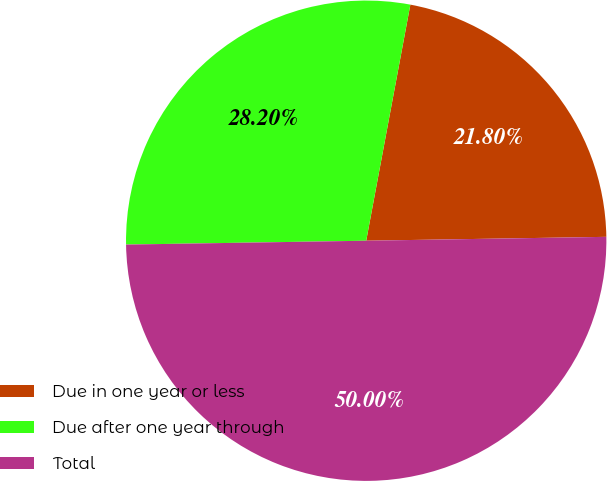Convert chart to OTSL. <chart><loc_0><loc_0><loc_500><loc_500><pie_chart><fcel>Due in one year or less<fcel>Due after one year through<fcel>Total<nl><fcel>21.8%<fcel>28.2%<fcel>50.0%<nl></chart> 